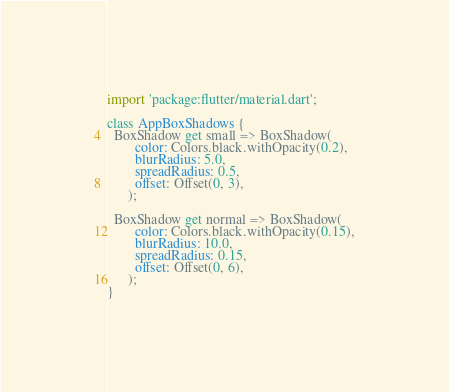<code> <loc_0><loc_0><loc_500><loc_500><_Dart_>import 'package:flutter/material.dart';

class AppBoxShadows {
  BoxShadow get small => BoxShadow(
        color: Colors.black.withOpacity(0.2),
        blurRadius: 5.0,
        spreadRadius: 0.5,
        offset: Offset(0, 3),
      );

  BoxShadow get normal => BoxShadow(
        color: Colors.black.withOpacity(0.15),
        blurRadius: 10.0,
        spreadRadius: 0.15,
        offset: Offset(0, 6),
      );
}
</code> 